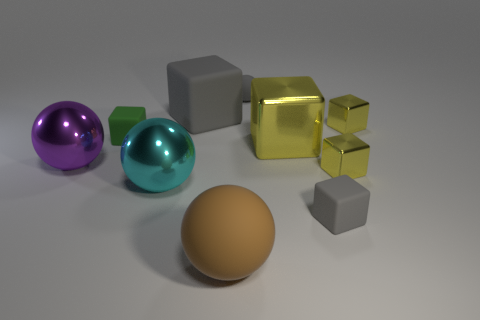Are there any other things that are the same size as the gray rubber sphere?
Your answer should be compact. Yes. Are there fewer big metal objects behind the tiny green rubber cube than gray balls behind the tiny matte ball?
Your answer should be compact. No. Is there any other thing that is the same shape as the big brown matte thing?
Ensure brevity in your answer.  Yes. There is a tiny cube that is the same color as the large matte cube; what is its material?
Offer a terse response. Rubber. How many yellow shiny things are on the left side of the gray object that is in front of the large matte thing behind the big purple ball?
Offer a terse response. 1. How many cyan metal things are right of the small rubber sphere?
Your answer should be compact. 0. How many large purple things are made of the same material as the tiny ball?
Your answer should be very brief. 0. The large block that is the same material as the small green cube is what color?
Your response must be concise. Gray. What is the small gray thing that is in front of the tiny thing that is behind the gray rubber block that is to the left of the brown thing made of?
Your answer should be compact. Rubber. Does the shiny ball that is in front of the purple sphere have the same size as the gray rubber ball?
Your answer should be compact. No. 